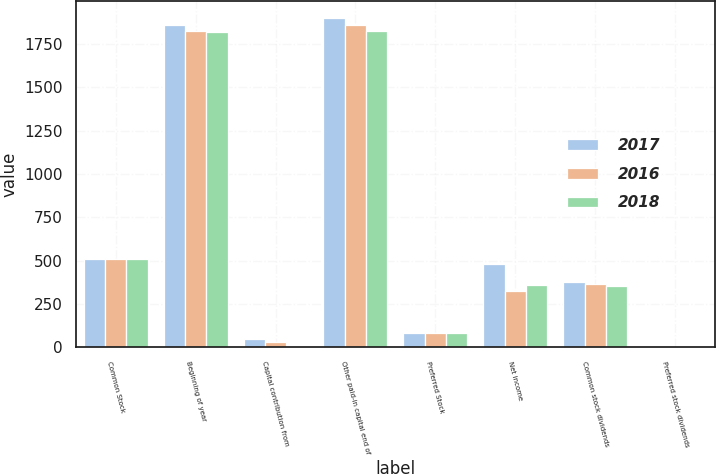<chart> <loc_0><loc_0><loc_500><loc_500><stacked_bar_chart><ecel><fcel>Common Stock<fcel>Beginning of year<fcel>Capital contribution from<fcel>Other paid-in capital end of<fcel>Preferred Stock<fcel>Net income<fcel>Common stock dividends<fcel>Preferred stock dividends<nl><fcel>2017<fcel>511<fcel>1858<fcel>45<fcel>1903<fcel>80<fcel>481<fcel>375<fcel>3<nl><fcel>2016<fcel>511<fcel>1828<fcel>30<fcel>1858<fcel>80<fcel>326<fcel>362<fcel>3<nl><fcel>2018<fcel>511<fcel>1822<fcel>6<fcel>1828<fcel>80<fcel>360<fcel>355<fcel>3<nl></chart> 